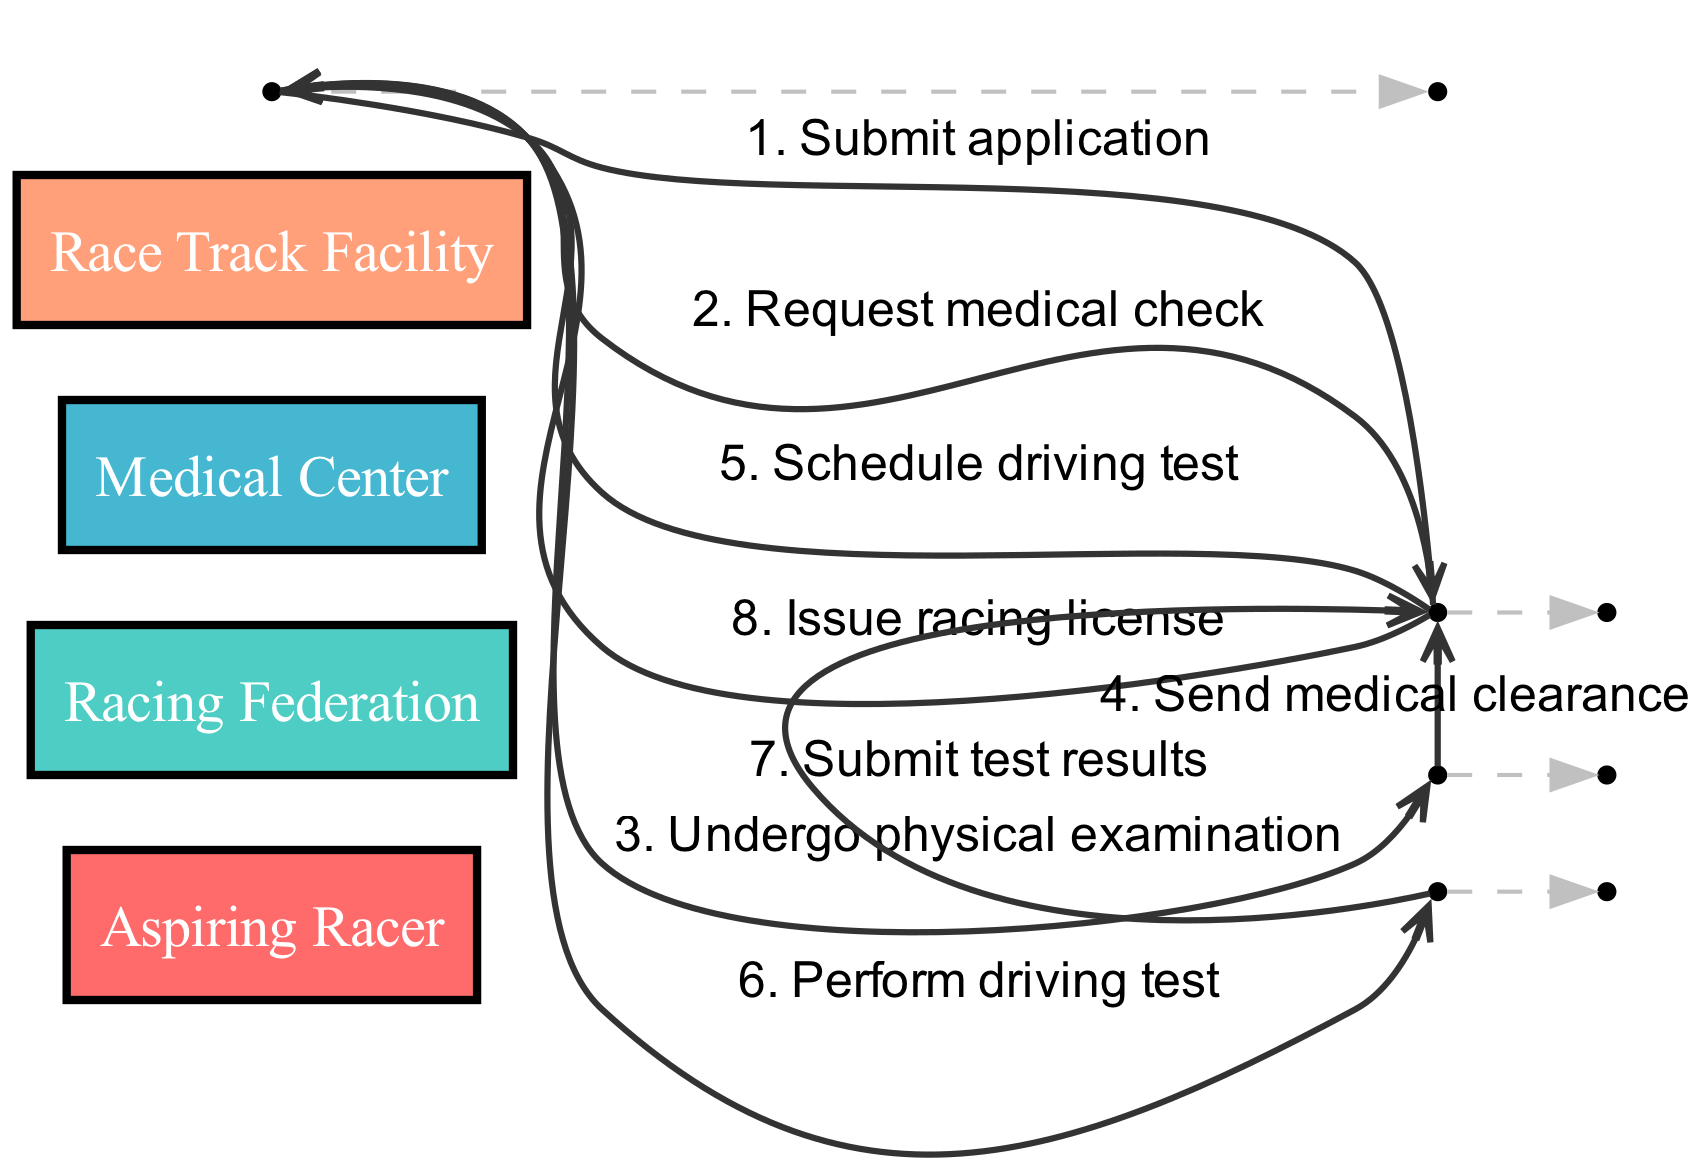What is the first action taken by the Aspiring Racer? The Aspiring Racer starts the process by submitting an application to the Racing Federation, which is the first action shown in the diagram.
Answer: Submit application How many actors are involved in this sequence diagram? The diagram includes four actors: Aspiring Racer, Racing Federation, Medical Center, and Race Track Facility. Counting them gives a total of four actors.
Answer: Four Which entity requests the medical check? The Racing Federation is responsible for requesting the medical check from the Aspiring Racer after the application is submitted. This is clearly indicated as the second action in the sequence.
Answer: Racing Federation What action follows the completion of the physical examination? After the Aspiring Racer undergoes the physical examination at the Medical Center, the next action is for the Medical Center to send the medical clearance to the Racing Federation. This is the fourth step in the sequence.
Answer: Send medical clearance After scheduling the driving test, who does the Aspiring Racer perform the test with? Following the scheduling of the driving test by the Racing Federation, the Aspiring Racer performs the driving test at the Race Track Facility. This relationship is evident as the Aspiring Racer is indicated to interact with the Race Track Facility after the driving test is scheduled.
Answer: Race Track Facility What is the last action that occurs in the sequence? The final action in the sequence diagram is the Racing Federation issuing the racing license to the Aspiring Racer after receiving test results from the Race Track Facility. This is the eighth and last step in the process.
Answer: Issue racing license Which actor submits the test results? The test results are submitted by the Race Track Facility to the Racing Federation after the Aspiring Racer performs the driving test. This establishes the connection and flow between these two actors.
Answer: Race Track Facility How many steps are there from application submission to issuing a license? There are a total of eight steps that progress from the initial submission of the application by the Aspiring Racer to the issuance of the racing license by the Racing Federation, indicating that it is a sequential process with multiple actions involved.
Answer: Eight 